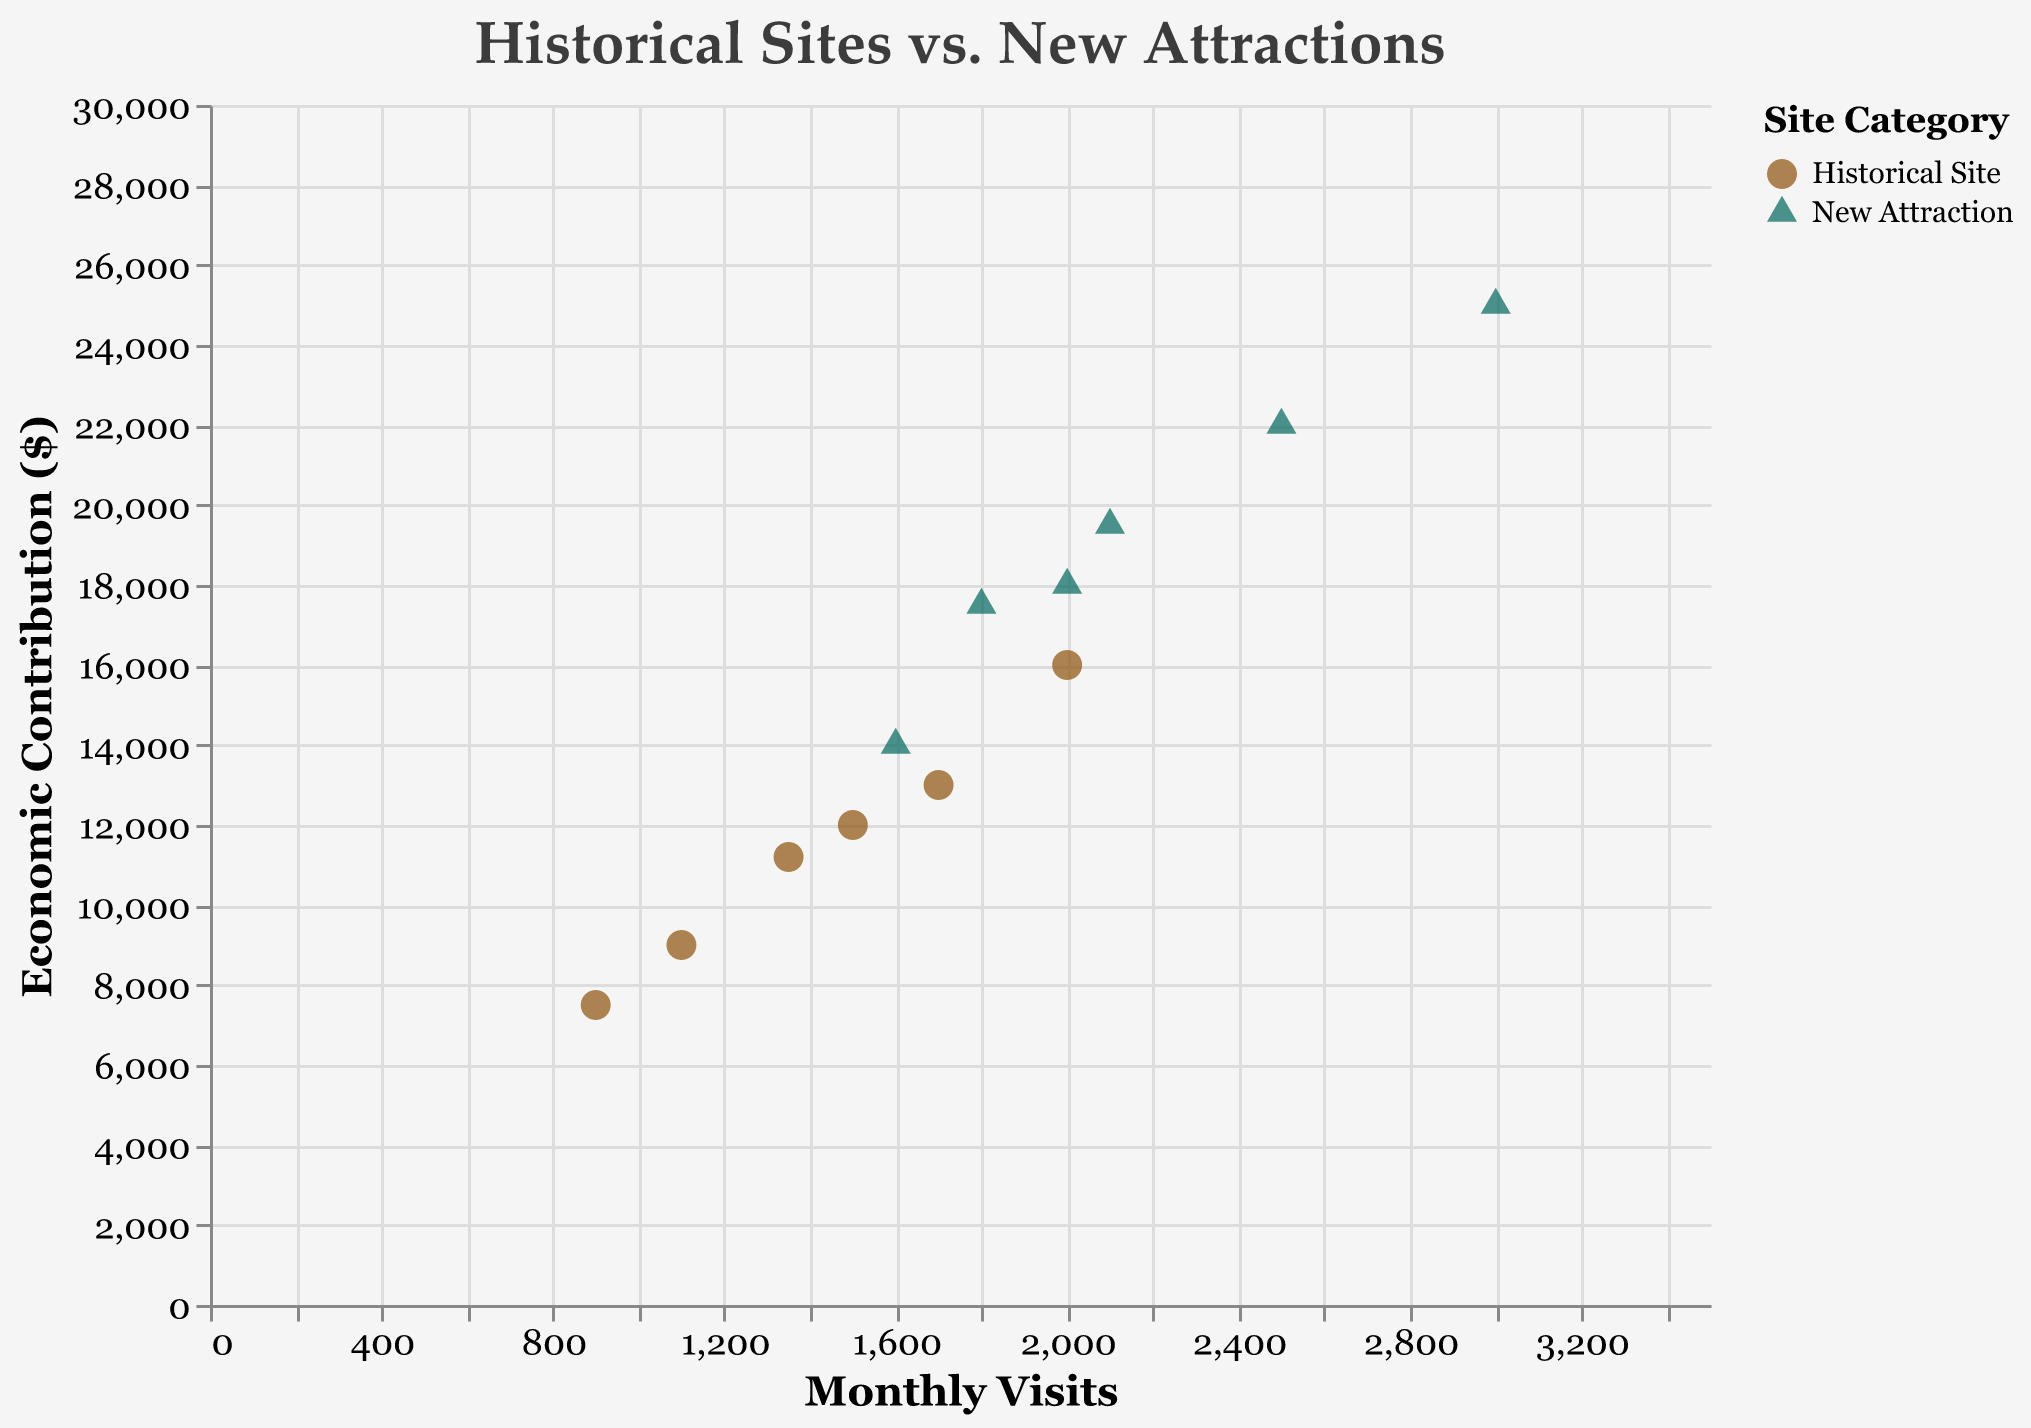What is the title of the figure? The title is usually placed at the top of the figure and provides a summary of what the data visualization represents. The title of this figure is "Historical Sites vs. New Attractions".
Answer: Historical Sites vs. New Attractions What does the x-axis represent? The x-axis is labeled "Monthly Visits". This indicates that the x-axis represents the number of visits per month.
Answer: Monthly Visits What shapes are used to represent historical sites and new attractions? The legend indicates that circles represent historical sites and triangles represent new attractions.
Answer: Circles and triangles Which site has the highest economic contribution for historical sites? Looking at the economic contributions for historical sites on the y-axis, the highest value reaches $16000 for Town Square Market.
Answer: Town Square Market Which site has the highest number of monthly visits for new attractions? The x-axis shows the monthly visits, and the highest value for new attractions is 3000 at Liberty Gardens.
Answer: Liberty Gardens What is the economic contribution of Victorian Theatre's new attraction? The tooltip indicates that Victorian Theatre's new attraction has an economic contribution value of $19500.
Answer: $19500 What is the average economic contribution of the new attractions? Find the economic contribution values for each new attraction (18000, 22000, 14000, 25000, 19500, 17500), sum them up to get 116000, and then divide by the number of new attractions (6).
Answer: 19333.33 By how much does the monthly visit of Liberty Gardens' new attraction exceed its historical site? For Liberty Gardens, subtract the historical site's monthly visits (900) from the new attraction's monthly visits (3000). So, 3000 - 900 = 2100.
Answer: 2100 Which category, historical sites or new attractions, generally contributes more economically to local businesses? By comparing the overall trends of economic contributions on the y-axis, new attractions generally contribute more as seen from their higher y-axis values in comparison to historical sites.
Answer: New attractions What is the correlation between monthly visits and economic contributions for new attractions and historical sites? By observing the scatter plot points, both categories show a positive correlation; as monthly visits increase, economic contributions also increase.
Answer: Positive correlation for both 